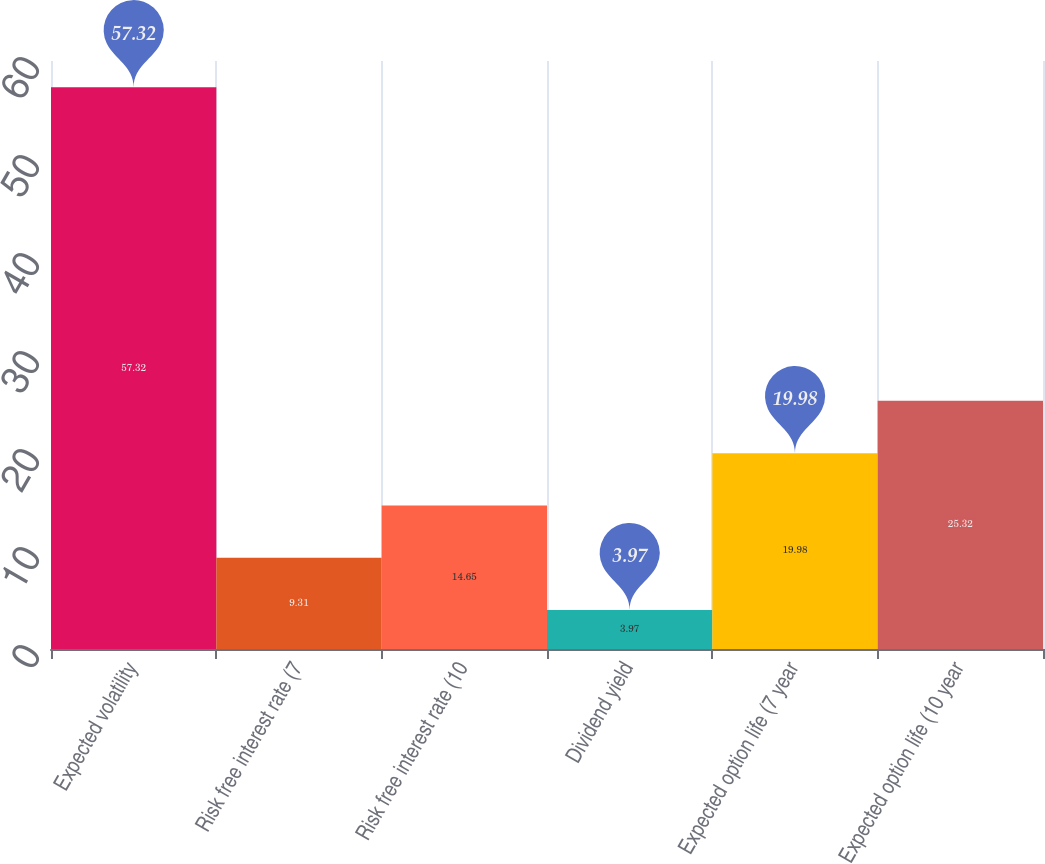<chart> <loc_0><loc_0><loc_500><loc_500><bar_chart><fcel>Expected volatility<fcel>Risk free interest rate (7<fcel>Risk free interest rate (10<fcel>Dividend yield<fcel>Expected option life (7 year<fcel>Expected option life (10 year<nl><fcel>57.32<fcel>9.31<fcel>14.65<fcel>3.97<fcel>19.98<fcel>25.32<nl></chart> 